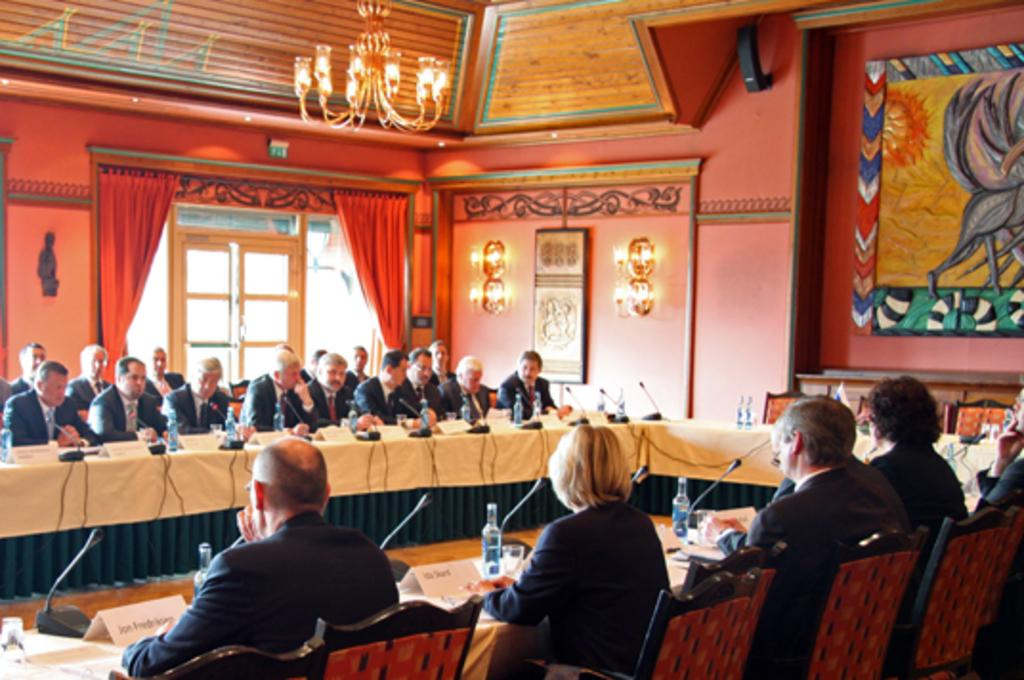What are the people in the image doing? There is a group of people sitting on chairs in the image. What objects can be seen on the table in the image? There is a mix and a bottle on the table in the image. What else is on the table? There is also a glass on the table. What is visible at the back of the image? There is a wall at the back side of the image. Can you describe the lighting in the image? There is light visible in the image. What type of reading material is being used in the competition in the image? There is no reading material or competition present in the image. 